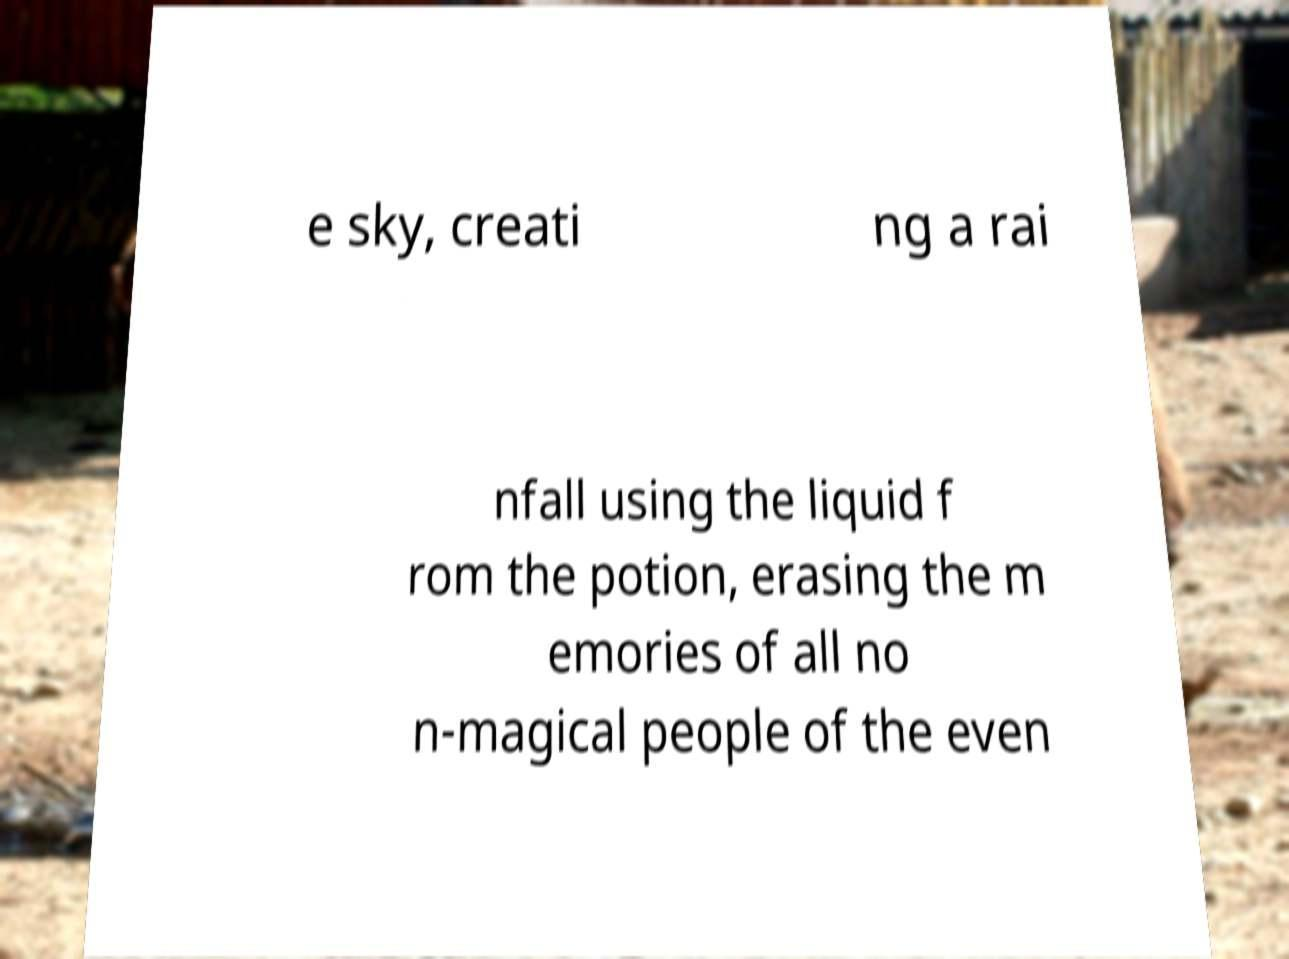What messages or text are displayed in this image? I need them in a readable, typed format. e sky, creati ng a rai nfall using the liquid f rom the potion, erasing the m emories of all no n-magical people of the even 